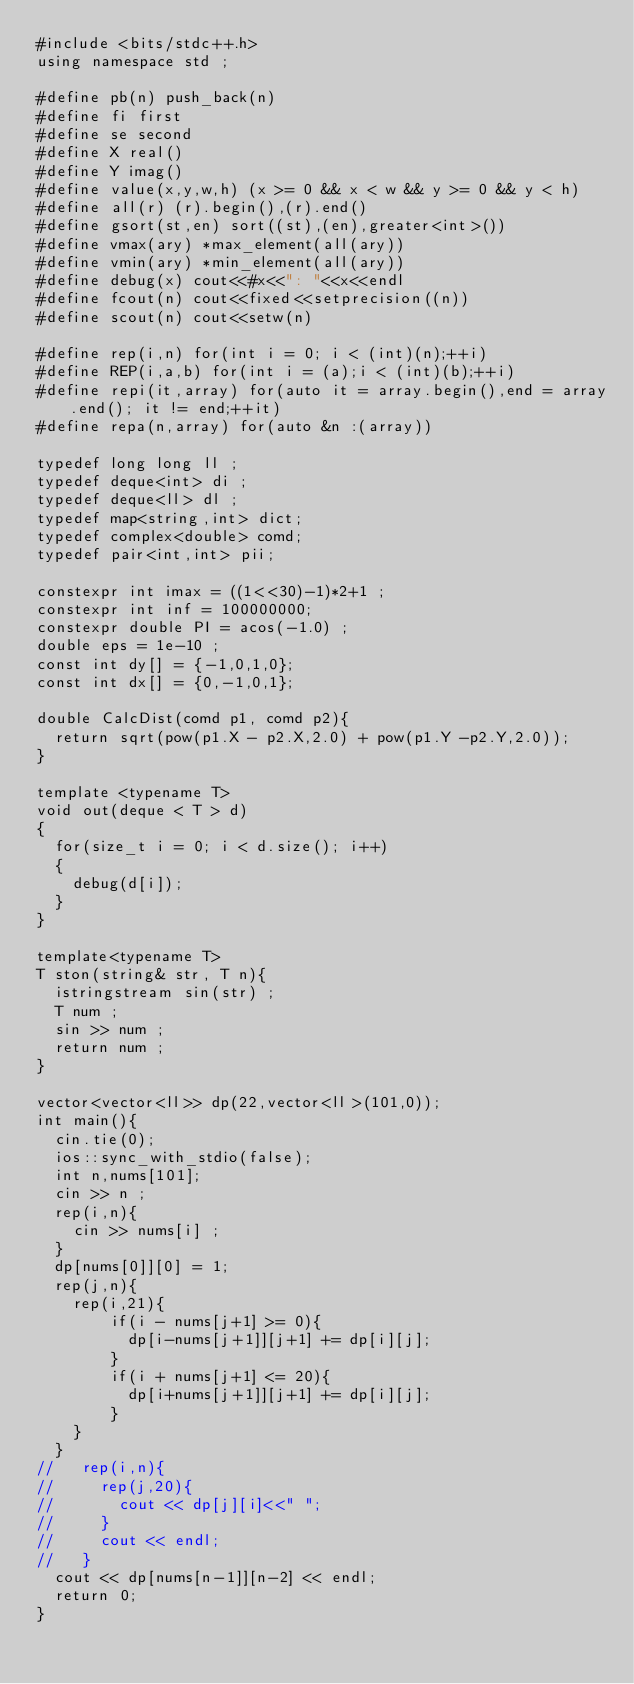<code> <loc_0><loc_0><loc_500><loc_500><_C++_>#include <bits/stdc++.h>
using namespace std ;

#define pb(n) push_back(n)
#define fi first
#define se second
#define X real()
#define Y imag()
#define value(x,y,w,h) (x >= 0 && x < w && y >= 0 && y < h)
#define all(r) (r).begin(),(r).end()
#define gsort(st,en) sort((st),(en),greater<int>())
#define vmax(ary) *max_element(all(ary))
#define vmin(ary) *min_element(all(ary))
#define debug(x) cout<<#x<<": "<<x<<endl
#define fcout(n) cout<<fixed<<setprecision((n))
#define scout(n) cout<<setw(n)

#define rep(i,n) for(int i = 0; i < (int)(n);++i)
#define REP(i,a,b) for(int i = (a);i < (int)(b);++i)
#define repi(it,array) for(auto it = array.begin(),end = array.end(); it != end;++it)
#define repa(n,array) for(auto &n :(array))

typedef long long ll ;
typedef deque<int> di ;
typedef deque<ll> dl ;
typedef map<string,int> dict;
typedef complex<double> comd;
typedef pair<int,int> pii;

constexpr int imax = ((1<<30)-1)*2+1 ;
constexpr int inf = 100000000;
constexpr double PI = acos(-1.0) ;
double eps = 1e-10 ;
const int dy[] = {-1,0,1,0};
const int dx[] = {0,-1,0,1};

double CalcDist(comd p1, comd p2){
  return sqrt(pow(p1.X - p2.X,2.0) + pow(p1.Y -p2.Y,2.0));
}

template <typename T>
void out(deque < T > d)
{
  for(size_t i = 0; i < d.size(); i++)
  {
    debug(d[i]);
  }
}

template<typename T>
T ston(string& str, T n){
  istringstream sin(str) ;
  T num ;
  sin >> num ;
  return num ;
}

vector<vector<ll>> dp(22,vector<ll>(101,0));
int main(){
  cin.tie(0);
  ios::sync_with_stdio(false);
  int n,nums[101];
  cin >> n ;
  rep(i,n){
    cin >> nums[i] ;
  }
  dp[nums[0]][0] = 1;
  rep(j,n){
    rep(i,21){
        if(i - nums[j+1] >= 0){
          dp[i-nums[j+1]][j+1] += dp[i][j];
        }
        if(i + nums[j+1] <= 20){
          dp[i+nums[j+1]][j+1] += dp[i][j];
        }
    }
  }
//   rep(i,n){
//     rep(j,20){
//       cout << dp[j][i]<<" ";
//     }
//     cout << endl;
//   }
  cout << dp[nums[n-1]][n-2] << endl;
  return 0;
}</code> 